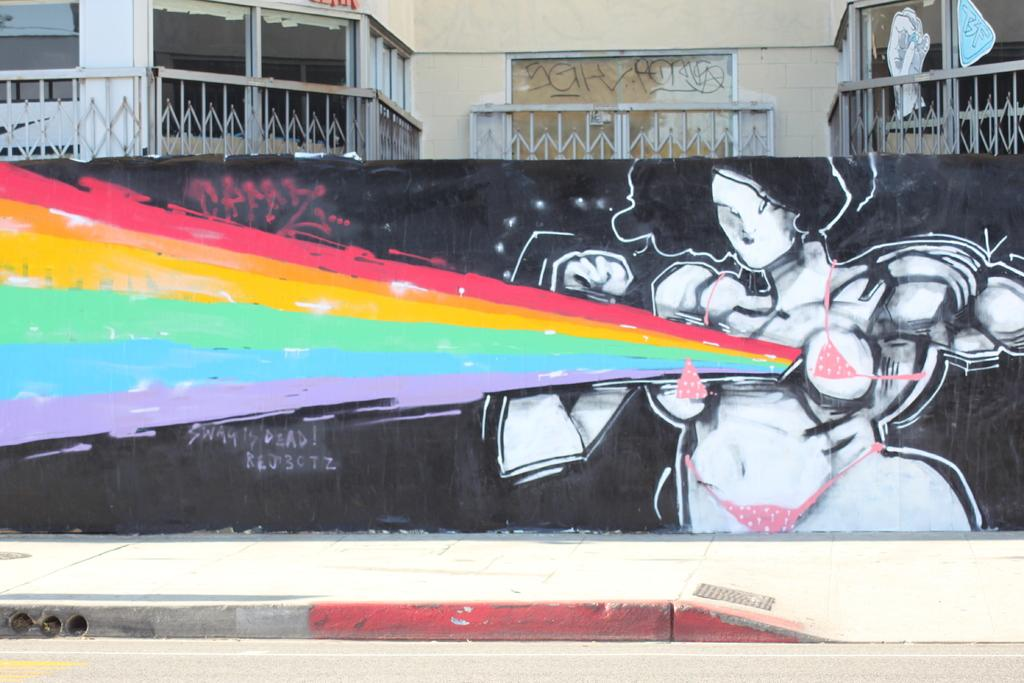What is the main feature in the center of the image? There is a road in the center of the image. What can be seen on the side of the road? There is a wall in the image. What is on the wall? Graffiti is present on the wall. What is visible in the background of the image? There is a building, windows, posters, and fences in the background of the image. Can you see a bike being blown away by a gun in the image? No, there is no bike, blowing, or gun present in the image. 